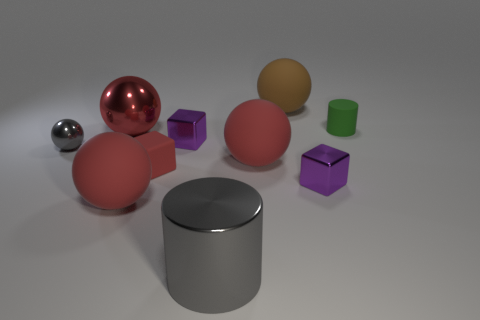Subtract all red blocks. How many blocks are left? 2 Subtract all gray balls. How many balls are left? 4 Subtract all cylinders. How many objects are left? 8 Subtract 1 balls. How many balls are left? 4 Subtract all gray cylinders. Subtract all blue spheres. How many cylinders are left? 1 Subtract all brown spheres. How many green cylinders are left? 1 Subtract all red spheres. Subtract all brown things. How many objects are left? 6 Add 1 spheres. How many spheres are left? 6 Add 3 tiny purple shiny objects. How many tiny purple shiny objects exist? 5 Subtract 0 purple spheres. How many objects are left? 10 